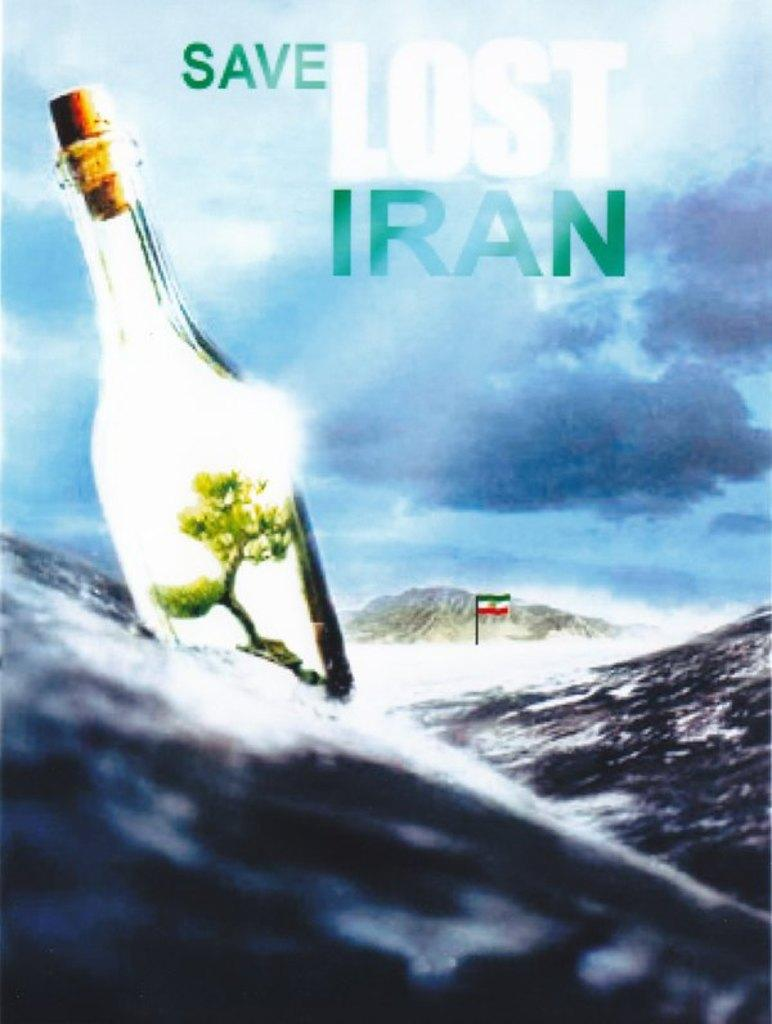<image>
Offer a succinct explanation of the picture presented. An advertisement with a floating bottle in the water with the words save lost Iran at the top. 